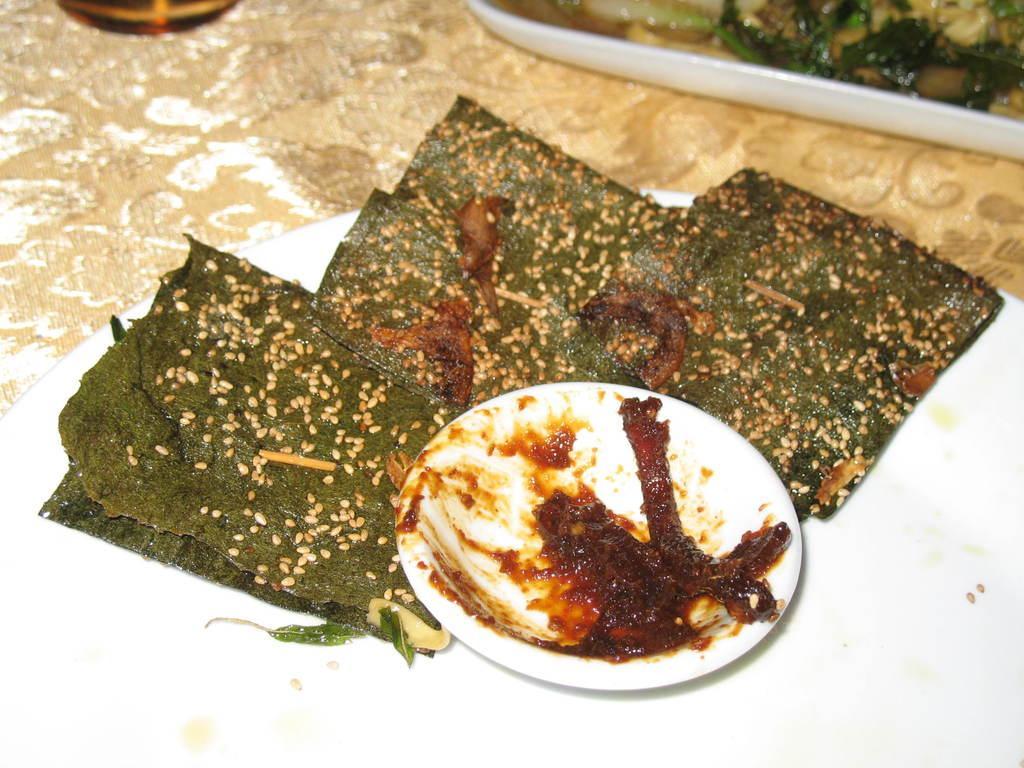Can you describe this image briefly? In the foreground of this image, there is some food item on a platter and also a white bowl with some food on it. At the top, there is some food in a white platter and an object on the cream surface. 